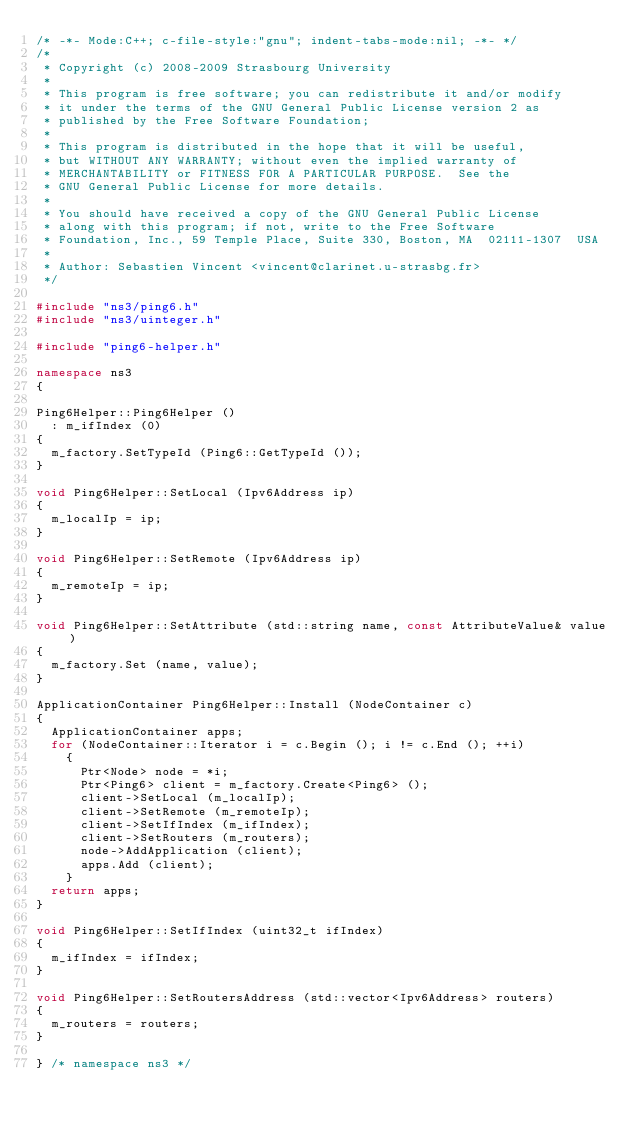<code> <loc_0><loc_0><loc_500><loc_500><_C++_>/* -*- Mode:C++; c-file-style:"gnu"; indent-tabs-mode:nil; -*- */
/*
 * Copyright (c) 2008-2009 Strasbourg University
 *
 * This program is free software; you can redistribute it and/or modify
 * it under the terms of the GNU General Public License version 2 as
 * published by the Free Software Foundation;
 *
 * This program is distributed in the hope that it will be useful,
 * but WITHOUT ANY WARRANTY; without even the implied warranty of
 * MERCHANTABILITY or FITNESS FOR A PARTICULAR PURPOSE.  See the
 * GNU General Public License for more details.
 *
 * You should have received a copy of the GNU General Public License
 * along with this program; if not, write to the Free Software
 * Foundation, Inc., 59 Temple Place, Suite 330, Boston, MA  02111-1307  USA
 *
 * Author: Sebastien Vincent <vincent@clarinet.u-strasbg.fr>
 */

#include "ns3/ping6.h"
#include "ns3/uinteger.h"

#include "ping6-helper.h"

namespace ns3
{

Ping6Helper::Ping6Helper ()
  : m_ifIndex (0)
{
  m_factory.SetTypeId (Ping6::GetTypeId ());
}

void Ping6Helper::SetLocal (Ipv6Address ip)
{
  m_localIp = ip;
}

void Ping6Helper::SetRemote (Ipv6Address ip)
{
  m_remoteIp = ip;
}

void Ping6Helper::SetAttribute (std::string name, const AttributeValue& value)
{
  m_factory.Set (name, value);
}

ApplicationContainer Ping6Helper::Install (NodeContainer c)
{
  ApplicationContainer apps;
  for (NodeContainer::Iterator i = c.Begin (); i != c.End (); ++i)
    {
      Ptr<Node> node = *i;
      Ptr<Ping6> client = m_factory.Create<Ping6> ();
      client->SetLocal (m_localIp);
      client->SetRemote (m_remoteIp);
      client->SetIfIndex (m_ifIndex);
      client->SetRouters (m_routers);
      node->AddApplication (client);
      apps.Add (client);
    }
  return apps;
}

void Ping6Helper::SetIfIndex (uint32_t ifIndex)
{
  m_ifIndex = ifIndex;
}

void Ping6Helper::SetRoutersAddress (std::vector<Ipv6Address> routers)
{
  m_routers = routers;
}

} /* namespace ns3 */

</code> 